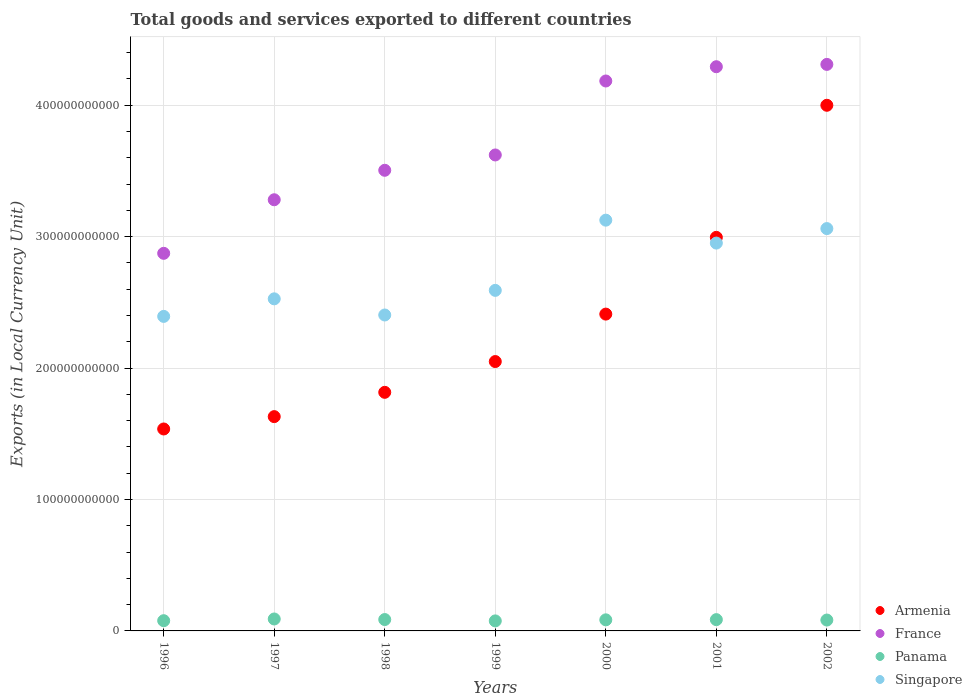How many different coloured dotlines are there?
Your response must be concise. 4. What is the Amount of goods and services exports in France in 1998?
Make the answer very short. 3.51e+11. Across all years, what is the maximum Amount of goods and services exports in Panama?
Offer a very short reply. 9.09e+09. Across all years, what is the minimum Amount of goods and services exports in Armenia?
Your answer should be very brief. 1.54e+11. In which year was the Amount of goods and services exports in France minimum?
Give a very brief answer. 1996. What is the total Amount of goods and services exports in France in the graph?
Ensure brevity in your answer.  2.61e+12. What is the difference between the Amount of goods and services exports in Armenia in 1996 and that in 2001?
Make the answer very short. -1.46e+11. What is the difference between the Amount of goods and services exports in France in 2000 and the Amount of goods and services exports in Singapore in 1996?
Keep it short and to the point. 1.79e+11. What is the average Amount of goods and services exports in Armenia per year?
Offer a terse response. 2.35e+11. In the year 1998, what is the difference between the Amount of goods and services exports in Singapore and Amount of goods and services exports in Panama?
Offer a terse response. 2.32e+11. What is the ratio of the Amount of goods and services exports in Singapore in 2000 to that in 2001?
Keep it short and to the point. 1.06. Is the Amount of goods and services exports in Singapore in 1997 less than that in 1998?
Provide a succinct answer. No. Is the difference between the Amount of goods and services exports in Singapore in 1997 and 1998 greater than the difference between the Amount of goods and services exports in Panama in 1997 and 1998?
Your response must be concise. Yes. What is the difference between the highest and the second highest Amount of goods and services exports in France?
Your response must be concise. 1.77e+09. What is the difference between the highest and the lowest Amount of goods and services exports in Panama?
Offer a terse response. 1.46e+09. Is the sum of the Amount of goods and services exports in Armenia in 1998 and 2000 greater than the maximum Amount of goods and services exports in Singapore across all years?
Provide a succinct answer. Yes. Is it the case that in every year, the sum of the Amount of goods and services exports in Panama and Amount of goods and services exports in France  is greater than the Amount of goods and services exports in Armenia?
Your response must be concise. Yes. Does the Amount of goods and services exports in Panama monotonically increase over the years?
Give a very brief answer. No. Is the Amount of goods and services exports in Panama strictly greater than the Amount of goods and services exports in France over the years?
Provide a short and direct response. No. What is the difference between two consecutive major ticks on the Y-axis?
Your response must be concise. 1.00e+11. Does the graph contain any zero values?
Provide a succinct answer. No. How are the legend labels stacked?
Offer a very short reply. Vertical. What is the title of the graph?
Give a very brief answer. Total goods and services exported to different countries. Does "Papua New Guinea" appear as one of the legend labels in the graph?
Give a very brief answer. No. What is the label or title of the X-axis?
Your response must be concise. Years. What is the label or title of the Y-axis?
Your answer should be compact. Exports (in Local Currency Unit). What is the Exports (in Local Currency Unit) in Armenia in 1996?
Ensure brevity in your answer.  1.54e+11. What is the Exports (in Local Currency Unit) of France in 1996?
Make the answer very short. 2.87e+11. What is the Exports (in Local Currency Unit) of Panama in 1996?
Make the answer very short. 7.78e+09. What is the Exports (in Local Currency Unit) of Singapore in 1996?
Give a very brief answer. 2.39e+11. What is the Exports (in Local Currency Unit) of Armenia in 1997?
Offer a terse response. 1.63e+11. What is the Exports (in Local Currency Unit) of France in 1997?
Your answer should be compact. 3.28e+11. What is the Exports (in Local Currency Unit) of Panama in 1997?
Your response must be concise. 9.09e+09. What is the Exports (in Local Currency Unit) of Singapore in 1997?
Ensure brevity in your answer.  2.53e+11. What is the Exports (in Local Currency Unit) in Armenia in 1998?
Your answer should be compact. 1.82e+11. What is the Exports (in Local Currency Unit) in France in 1998?
Your answer should be very brief. 3.51e+11. What is the Exports (in Local Currency Unit) in Panama in 1998?
Your answer should be very brief. 8.66e+09. What is the Exports (in Local Currency Unit) in Singapore in 1998?
Provide a succinct answer. 2.40e+11. What is the Exports (in Local Currency Unit) of Armenia in 1999?
Make the answer very short. 2.05e+11. What is the Exports (in Local Currency Unit) in France in 1999?
Keep it short and to the point. 3.62e+11. What is the Exports (in Local Currency Unit) of Panama in 1999?
Your response must be concise. 7.62e+09. What is the Exports (in Local Currency Unit) of Singapore in 1999?
Ensure brevity in your answer.  2.59e+11. What is the Exports (in Local Currency Unit) in Armenia in 2000?
Provide a short and direct response. 2.41e+11. What is the Exports (in Local Currency Unit) of France in 2000?
Your answer should be very brief. 4.18e+11. What is the Exports (in Local Currency Unit) in Panama in 2000?
Keep it short and to the point. 8.43e+09. What is the Exports (in Local Currency Unit) in Singapore in 2000?
Your answer should be very brief. 3.13e+11. What is the Exports (in Local Currency Unit) of Armenia in 2001?
Offer a very short reply. 2.99e+11. What is the Exports (in Local Currency Unit) of France in 2001?
Ensure brevity in your answer.  4.29e+11. What is the Exports (in Local Currency Unit) of Panama in 2001?
Provide a short and direct response. 8.59e+09. What is the Exports (in Local Currency Unit) in Singapore in 2001?
Ensure brevity in your answer.  2.95e+11. What is the Exports (in Local Currency Unit) in Armenia in 2002?
Offer a very short reply. 4.00e+11. What is the Exports (in Local Currency Unit) of France in 2002?
Ensure brevity in your answer.  4.31e+11. What is the Exports (in Local Currency Unit) of Panama in 2002?
Your answer should be compact. 8.28e+09. What is the Exports (in Local Currency Unit) of Singapore in 2002?
Your response must be concise. 3.06e+11. Across all years, what is the maximum Exports (in Local Currency Unit) of Armenia?
Your answer should be compact. 4.00e+11. Across all years, what is the maximum Exports (in Local Currency Unit) in France?
Provide a short and direct response. 4.31e+11. Across all years, what is the maximum Exports (in Local Currency Unit) in Panama?
Give a very brief answer. 9.09e+09. Across all years, what is the maximum Exports (in Local Currency Unit) of Singapore?
Provide a succinct answer. 3.13e+11. Across all years, what is the minimum Exports (in Local Currency Unit) in Armenia?
Offer a terse response. 1.54e+11. Across all years, what is the minimum Exports (in Local Currency Unit) of France?
Offer a terse response. 2.87e+11. Across all years, what is the minimum Exports (in Local Currency Unit) of Panama?
Your answer should be very brief. 7.62e+09. Across all years, what is the minimum Exports (in Local Currency Unit) of Singapore?
Your answer should be very brief. 2.39e+11. What is the total Exports (in Local Currency Unit) in Armenia in the graph?
Provide a succinct answer. 1.64e+12. What is the total Exports (in Local Currency Unit) of France in the graph?
Provide a succinct answer. 2.61e+12. What is the total Exports (in Local Currency Unit) in Panama in the graph?
Offer a very short reply. 5.84e+1. What is the total Exports (in Local Currency Unit) of Singapore in the graph?
Your response must be concise. 1.91e+12. What is the difference between the Exports (in Local Currency Unit) in Armenia in 1996 and that in 1997?
Give a very brief answer. -9.40e+09. What is the difference between the Exports (in Local Currency Unit) in France in 1996 and that in 1997?
Offer a terse response. -4.08e+1. What is the difference between the Exports (in Local Currency Unit) of Panama in 1996 and that in 1997?
Make the answer very short. -1.31e+09. What is the difference between the Exports (in Local Currency Unit) of Singapore in 1996 and that in 1997?
Provide a short and direct response. -1.34e+1. What is the difference between the Exports (in Local Currency Unit) of Armenia in 1996 and that in 1998?
Provide a succinct answer. -2.79e+1. What is the difference between the Exports (in Local Currency Unit) in France in 1996 and that in 1998?
Offer a terse response. -6.32e+1. What is the difference between the Exports (in Local Currency Unit) in Panama in 1996 and that in 1998?
Your answer should be very brief. -8.78e+08. What is the difference between the Exports (in Local Currency Unit) in Singapore in 1996 and that in 1998?
Provide a succinct answer. -1.06e+09. What is the difference between the Exports (in Local Currency Unit) in Armenia in 1996 and that in 1999?
Offer a very short reply. -5.13e+1. What is the difference between the Exports (in Local Currency Unit) of France in 1996 and that in 1999?
Keep it short and to the point. -7.49e+1. What is the difference between the Exports (in Local Currency Unit) in Panama in 1996 and that in 1999?
Your answer should be very brief. 1.55e+08. What is the difference between the Exports (in Local Currency Unit) of Singapore in 1996 and that in 1999?
Ensure brevity in your answer.  -1.98e+1. What is the difference between the Exports (in Local Currency Unit) of Armenia in 1996 and that in 2000?
Make the answer very short. -8.74e+1. What is the difference between the Exports (in Local Currency Unit) of France in 1996 and that in 2000?
Keep it short and to the point. -1.31e+11. What is the difference between the Exports (in Local Currency Unit) of Panama in 1996 and that in 2000?
Your answer should be compact. -6.56e+08. What is the difference between the Exports (in Local Currency Unit) of Singapore in 1996 and that in 2000?
Keep it short and to the point. -7.32e+1. What is the difference between the Exports (in Local Currency Unit) in Armenia in 1996 and that in 2001?
Your answer should be very brief. -1.46e+11. What is the difference between the Exports (in Local Currency Unit) of France in 1996 and that in 2001?
Your answer should be compact. -1.42e+11. What is the difference between the Exports (in Local Currency Unit) in Panama in 1996 and that in 2001?
Ensure brevity in your answer.  -8.09e+08. What is the difference between the Exports (in Local Currency Unit) of Singapore in 1996 and that in 2001?
Offer a very short reply. -5.58e+1. What is the difference between the Exports (in Local Currency Unit) in Armenia in 1996 and that in 2002?
Provide a succinct answer. -2.46e+11. What is the difference between the Exports (in Local Currency Unit) in France in 1996 and that in 2002?
Your answer should be very brief. -1.44e+11. What is the difference between the Exports (in Local Currency Unit) of Panama in 1996 and that in 2002?
Offer a very short reply. -5.01e+08. What is the difference between the Exports (in Local Currency Unit) of Singapore in 1996 and that in 2002?
Your answer should be very brief. -6.68e+1. What is the difference between the Exports (in Local Currency Unit) in Armenia in 1997 and that in 1998?
Make the answer very short. -1.85e+1. What is the difference between the Exports (in Local Currency Unit) in France in 1997 and that in 1998?
Offer a terse response. -2.24e+1. What is the difference between the Exports (in Local Currency Unit) in Panama in 1997 and that in 1998?
Give a very brief answer. 4.30e+08. What is the difference between the Exports (in Local Currency Unit) in Singapore in 1997 and that in 1998?
Provide a short and direct response. 1.23e+1. What is the difference between the Exports (in Local Currency Unit) in Armenia in 1997 and that in 1999?
Your answer should be very brief. -4.19e+1. What is the difference between the Exports (in Local Currency Unit) of France in 1997 and that in 1999?
Provide a short and direct response. -3.41e+1. What is the difference between the Exports (in Local Currency Unit) of Panama in 1997 and that in 1999?
Offer a very short reply. 1.46e+09. What is the difference between the Exports (in Local Currency Unit) in Singapore in 1997 and that in 1999?
Offer a terse response. -6.44e+09. What is the difference between the Exports (in Local Currency Unit) in Armenia in 1997 and that in 2000?
Your answer should be compact. -7.80e+1. What is the difference between the Exports (in Local Currency Unit) in France in 1997 and that in 2000?
Offer a very short reply. -9.04e+1. What is the difference between the Exports (in Local Currency Unit) of Panama in 1997 and that in 2000?
Your response must be concise. 6.53e+08. What is the difference between the Exports (in Local Currency Unit) of Singapore in 1997 and that in 2000?
Give a very brief answer. -5.99e+1. What is the difference between the Exports (in Local Currency Unit) of Armenia in 1997 and that in 2001?
Offer a terse response. -1.36e+11. What is the difference between the Exports (in Local Currency Unit) of France in 1997 and that in 2001?
Give a very brief answer. -1.01e+11. What is the difference between the Exports (in Local Currency Unit) in Panama in 1997 and that in 2001?
Your response must be concise. 5.00e+08. What is the difference between the Exports (in Local Currency Unit) in Singapore in 1997 and that in 2001?
Make the answer very short. -4.24e+1. What is the difference between the Exports (in Local Currency Unit) of Armenia in 1997 and that in 2002?
Keep it short and to the point. -2.37e+11. What is the difference between the Exports (in Local Currency Unit) in France in 1997 and that in 2002?
Your answer should be compact. -1.03e+11. What is the difference between the Exports (in Local Currency Unit) of Panama in 1997 and that in 2002?
Ensure brevity in your answer.  8.07e+08. What is the difference between the Exports (in Local Currency Unit) in Singapore in 1997 and that in 2002?
Your response must be concise. -5.35e+1. What is the difference between the Exports (in Local Currency Unit) in Armenia in 1998 and that in 1999?
Provide a succinct answer. -2.34e+1. What is the difference between the Exports (in Local Currency Unit) in France in 1998 and that in 1999?
Keep it short and to the point. -1.17e+1. What is the difference between the Exports (in Local Currency Unit) of Panama in 1998 and that in 1999?
Provide a succinct answer. 1.03e+09. What is the difference between the Exports (in Local Currency Unit) in Singapore in 1998 and that in 1999?
Provide a succinct answer. -1.87e+1. What is the difference between the Exports (in Local Currency Unit) of Armenia in 1998 and that in 2000?
Give a very brief answer. -5.95e+1. What is the difference between the Exports (in Local Currency Unit) in France in 1998 and that in 2000?
Your answer should be compact. -6.80e+1. What is the difference between the Exports (in Local Currency Unit) of Panama in 1998 and that in 2000?
Offer a very short reply. 2.22e+08. What is the difference between the Exports (in Local Currency Unit) in Singapore in 1998 and that in 2000?
Offer a terse response. -7.22e+1. What is the difference between the Exports (in Local Currency Unit) of Armenia in 1998 and that in 2001?
Provide a succinct answer. -1.18e+11. What is the difference between the Exports (in Local Currency Unit) of France in 1998 and that in 2001?
Offer a terse response. -7.88e+1. What is the difference between the Exports (in Local Currency Unit) in Panama in 1998 and that in 2001?
Keep it short and to the point. 6.96e+07. What is the difference between the Exports (in Local Currency Unit) of Singapore in 1998 and that in 2001?
Offer a very short reply. -5.47e+1. What is the difference between the Exports (in Local Currency Unit) of Armenia in 1998 and that in 2002?
Your answer should be very brief. -2.18e+11. What is the difference between the Exports (in Local Currency Unit) of France in 1998 and that in 2002?
Keep it short and to the point. -8.06e+1. What is the difference between the Exports (in Local Currency Unit) in Panama in 1998 and that in 2002?
Give a very brief answer. 3.77e+08. What is the difference between the Exports (in Local Currency Unit) in Singapore in 1998 and that in 2002?
Provide a short and direct response. -6.58e+1. What is the difference between the Exports (in Local Currency Unit) in Armenia in 1999 and that in 2000?
Keep it short and to the point. -3.61e+1. What is the difference between the Exports (in Local Currency Unit) of France in 1999 and that in 2000?
Give a very brief answer. -5.63e+1. What is the difference between the Exports (in Local Currency Unit) of Panama in 1999 and that in 2000?
Your answer should be compact. -8.11e+08. What is the difference between the Exports (in Local Currency Unit) in Singapore in 1999 and that in 2000?
Your response must be concise. -5.34e+1. What is the difference between the Exports (in Local Currency Unit) of Armenia in 1999 and that in 2001?
Your answer should be compact. -9.45e+1. What is the difference between the Exports (in Local Currency Unit) of France in 1999 and that in 2001?
Provide a succinct answer. -6.71e+1. What is the difference between the Exports (in Local Currency Unit) of Panama in 1999 and that in 2001?
Ensure brevity in your answer.  -9.64e+08. What is the difference between the Exports (in Local Currency Unit) in Singapore in 1999 and that in 2001?
Your answer should be compact. -3.60e+1. What is the difference between the Exports (in Local Currency Unit) of Armenia in 1999 and that in 2002?
Your response must be concise. -1.95e+11. What is the difference between the Exports (in Local Currency Unit) of France in 1999 and that in 2002?
Give a very brief answer. -6.89e+1. What is the difference between the Exports (in Local Currency Unit) of Panama in 1999 and that in 2002?
Provide a short and direct response. -6.56e+08. What is the difference between the Exports (in Local Currency Unit) of Singapore in 1999 and that in 2002?
Offer a very short reply. -4.70e+1. What is the difference between the Exports (in Local Currency Unit) in Armenia in 2000 and that in 2001?
Offer a very short reply. -5.84e+1. What is the difference between the Exports (in Local Currency Unit) of France in 2000 and that in 2001?
Your answer should be compact. -1.09e+1. What is the difference between the Exports (in Local Currency Unit) in Panama in 2000 and that in 2001?
Give a very brief answer. -1.53e+08. What is the difference between the Exports (in Local Currency Unit) in Singapore in 2000 and that in 2001?
Offer a very short reply. 1.74e+1. What is the difference between the Exports (in Local Currency Unit) in Armenia in 2000 and that in 2002?
Offer a very short reply. -1.59e+11. What is the difference between the Exports (in Local Currency Unit) of France in 2000 and that in 2002?
Provide a succinct answer. -1.26e+1. What is the difference between the Exports (in Local Currency Unit) of Panama in 2000 and that in 2002?
Ensure brevity in your answer.  1.55e+08. What is the difference between the Exports (in Local Currency Unit) of Singapore in 2000 and that in 2002?
Keep it short and to the point. 6.41e+09. What is the difference between the Exports (in Local Currency Unit) in Armenia in 2001 and that in 2002?
Offer a terse response. -1.00e+11. What is the difference between the Exports (in Local Currency Unit) in France in 2001 and that in 2002?
Keep it short and to the point. -1.77e+09. What is the difference between the Exports (in Local Currency Unit) in Panama in 2001 and that in 2002?
Offer a terse response. 3.08e+08. What is the difference between the Exports (in Local Currency Unit) of Singapore in 2001 and that in 2002?
Your answer should be very brief. -1.10e+1. What is the difference between the Exports (in Local Currency Unit) of Armenia in 1996 and the Exports (in Local Currency Unit) of France in 1997?
Offer a terse response. -1.74e+11. What is the difference between the Exports (in Local Currency Unit) in Armenia in 1996 and the Exports (in Local Currency Unit) in Panama in 1997?
Your answer should be compact. 1.45e+11. What is the difference between the Exports (in Local Currency Unit) of Armenia in 1996 and the Exports (in Local Currency Unit) of Singapore in 1997?
Provide a short and direct response. -9.90e+1. What is the difference between the Exports (in Local Currency Unit) in France in 1996 and the Exports (in Local Currency Unit) in Panama in 1997?
Offer a terse response. 2.78e+11. What is the difference between the Exports (in Local Currency Unit) of France in 1996 and the Exports (in Local Currency Unit) of Singapore in 1997?
Keep it short and to the point. 3.46e+1. What is the difference between the Exports (in Local Currency Unit) of Panama in 1996 and the Exports (in Local Currency Unit) of Singapore in 1997?
Make the answer very short. -2.45e+11. What is the difference between the Exports (in Local Currency Unit) of Armenia in 1996 and the Exports (in Local Currency Unit) of France in 1998?
Keep it short and to the point. -1.97e+11. What is the difference between the Exports (in Local Currency Unit) in Armenia in 1996 and the Exports (in Local Currency Unit) in Panama in 1998?
Provide a succinct answer. 1.45e+11. What is the difference between the Exports (in Local Currency Unit) in Armenia in 1996 and the Exports (in Local Currency Unit) in Singapore in 1998?
Offer a very short reply. -8.67e+1. What is the difference between the Exports (in Local Currency Unit) of France in 1996 and the Exports (in Local Currency Unit) of Panama in 1998?
Keep it short and to the point. 2.79e+11. What is the difference between the Exports (in Local Currency Unit) of France in 1996 and the Exports (in Local Currency Unit) of Singapore in 1998?
Your response must be concise. 4.69e+1. What is the difference between the Exports (in Local Currency Unit) in Panama in 1996 and the Exports (in Local Currency Unit) in Singapore in 1998?
Your answer should be very brief. -2.33e+11. What is the difference between the Exports (in Local Currency Unit) of Armenia in 1996 and the Exports (in Local Currency Unit) of France in 1999?
Provide a succinct answer. -2.09e+11. What is the difference between the Exports (in Local Currency Unit) in Armenia in 1996 and the Exports (in Local Currency Unit) in Panama in 1999?
Ensure brevity in your answer.  1.46e+11. What is the difference between the Exports (in Local Currency Unit) of Armenia in 1996 and the Exports (in Local Currency Unit) of Singapore in 1999?
Keep it short and to the point. -1.05e+11. What is the difference between the Exports (in Local Currency Unit) in France in 1996 and the Exports (in Local Currency Unit) in Panama in 1999?
Provide a succinct answer. 2.80e+11. What is the difference between the Exports (in Local Currency Unit) in France in 1996 and the Exports (in Local Currency Unit) in Singapore in 1999?
Your answer should be very brief. 2.82e+1. What is the difference between the Exports (in Local Currency Unit) in Panama in 1996 and the Exports (in Local Currency Unit) in Singapore in 1999?
Ensure brevity in your answer.  -2.51e+11. What is the difference between the Exports (in Local Currency Unit) of Armenia in 1996 and the Exports (in Local Currency Unit) of France in 2000?
Give a very brief answer. -2.65e+11. What is the difference between the Exports (in Local Currency Unit) in Armenia in 1996 and the Exports (in Local Currency Unit) in Panama in 2000?
Offer a terse response. 1.45e+11. What is the difference between the Exports (in Local Currency Unit) of Armenia in 1996 and the Exports (in Local Currency Unit) of Singapore in 2000?
Make the answer very short. -1.59e+11. What is the difference between the Exports (in Local Currency Unit) of France in 1996 and the Exports (in Local Currency Unit) of Panama in 2000?
Provide a short and direct response. 2.79e+11. What is the difference between the Exports (in Local Currency Unit) of France in 1996 and the Exports (in Local Currency Unit) of Singapore in 2000?
Provide a short and direct response. -2.52e+1. What is the difference between the Exports (in Local Currency Unit) in Panama in 1996 and the Exports (in Local Currency Unit) in Singapore in 2000?
Offer a terse response. -3.05e+11. What is the difference between the Exports (in Local Currency Unit) in Armenia in 1996 and the Exports (in Local Currency Unit) in France in 2001?
Offer a very short reply. -2.76e+11. What is the difference between the Exports (in Local Currency Unit) in Armenia in 1996 and the Exports (in Local Currency Unit) in Panama in 2001?
Give a very brief answer. 1.45e+11. What is the difference between the Exports (in Local Currency Unit) of Armenia in 1996 and the Exports (in Local Currency Unit) of Singapore in 2001?
Keep it short and to the point. -1.41e+11. What is the difference between the Exports (in Local Currency Unit) of France in 1996 and the Exports (in Local Currency Unit) of Panama in 2001?
Provide a short and direct response. 2.79e+11. What is the difference between the Exports (in Local Currency Unit) in France in 1996 and the Exports (in Local Currency Unit) in Singapore in 2001?
Give a very brief answer. -7.80e+09. What is the difference between the Exports (in Local Currency Unit) in Panama in 1996 and the Exports (in Local Currency Unit) in Singapore in 2001?
Make the answer very short. -2.87e+11. What is the difference between the Exports (in Local Currency Unit) of Armenia in 1996 and the Exports (in Local Currency Unit) of France in 2002?
Keep it short and to the point. -2.77e+11. What is the difference between the Exports (in Local Currency Unit) in Armenia in 1996 and the Exports (in Local Currency Unit) in Panama in 2002?
Your answer should be compact. 1.45e+11. What is the difference between the Exports (in Local Currency Unit) of Armenia in 1996 and the Exports (in Local Currency Unit) of Singapore in 2002?
Ensure brevity in your answer.  -1.52e+11. What is the difference between the Exports (in Local Currency Unit) of France in 1996 and the Exports (in Local Currency Unit) of Panama in 2002?
Make the answer very short. 2.79e+11. What is the difference between the Exports (in Local Currency Unit) of France in 1996 and the Exports (in Local Currency Unit) of Singapore in 2002?
Ensure brevity in your answer.  -1.88e+1. What is the difference between the Exports (in Local Currency Unit) of Panama in 1996 and the Exports (in Local Currency Unit) of Singapore in 2002?
Provide a succinct answer. -2.98e+11. What is the difference between the Exports (in Local Currency Unit) of Armenia in 1997 and the Exports (in Local Currency Unit) of France in 1998?
Provide a succinct answer. -1.87e+11. What is the difference between the Exports (in Local Currency Unit) in Armenia in 1997 and the Exports (in Local Currency Unit) in Panama in 1998?
Keep it short and to the point. 1.54e+11. What is the difference between the Exports (in Local Currency Unit) of Armenia in 1997 and the Exports (in Local Currency Unit) of Singapore in 1998?
Offer a very short reply. -7.73e+1. What is the difference between the Exports (in Local Currency Unit) of France in 1997 and the Exports (in Local Currency Unit) of Panama in 1998?
Make the answer very short. 3.19e+11. What is the difference between the Exports (in Local Currency Unit) of France in 1997 and the Exports (in Local Currency Unit) of Singapore in 1998?
Your answer should be compact. 8.77e+1. What is the difference between the Exports (in Local Currency Unit) in Panama in 1997 and the Exports (in Local Currency Unit) in Singapore in 1998?
Your answer should be very brief. -2.31e+11. What is the difference between the Exports (in Local Currency Unit) in Armenia in 1997 and the Exports (in Local Currency Unit) in France in 1999?
Offer a very short reply. -1.99e+11. What is the difference between the Exports (in Local Currency Unit) in Armenia in 1997 and the Exports (in Local Currency Unit) in Panama in 1999?
Keep it short and to the point. 1.55e+11. What is the difference between the Exports (in Local Currency Unit) in Armenia in 1997 and the Exports (in Local Currency Unit) in Singapore in 1999?
Give a very brief answer. -9.61e+1. What is the difference between the Exports (in Local Currency Unit) of France in 1997 and the Exports (in Local Currency Unit) of Panama in 1999?
Your answer should be very brief. 3.20e+11. What is the difference between the Exports (in Local Currency Unit) of France in 1997 and the Exports (in Local Currency Unit) of Singapore in 1999?
Your answer should be compact. 6.90e+1. What is the difference between the Exports (in Local Currency Unit) in Panama in 1997 and the Exports (in Local Currency Unit) in Singapore in 1999?
Make the answer very short. -2.50e+11. What is the difference between the Exports (in Local Currency Unit) of Armenia in 1997 and the Exports (in Local Currency Unit) of France in 2000?
Offer a terse response. -2.55e+11. What is the difference between the Exports (in Local Currency Unit) in Armenia in 1997 and the Exports (in Local Currency Unit) in Panama in 2000?
Your answer should be compact. 1.55e+11. What is the difference between the Exports (in Local Currency Unit) of Armenia in 1997 and the Exports (in Local Currency Unit) of Singapore in 2000?
Your answer should be very brief. -1.49e+11. What is the difference between the Exports (in Local Currency Unit) of France in 1997 and the Exports (in Local Currency Unit) of Panama in 2000?
Provide a short and direct response. 3.20e+11. What is the difference between the Exports (in Local Currency Unit) of France in 1997 and the Exports (in Local Currency Unit) of Singapore in 2000?
Ensure brevity in your answer.  1.55e+1. What is the difference between the Exports (in Local Currency Unit) in Panama in 1997 and the Exports (in Local Currency Unit) in Singapore in 2000?
Keep it short and to the point. -3.03e+11. What is the difference between the Exports (in Local Currency Unit) in Armenia in 1997 and the Exports (in Local Currency Unit) in France in 2001?
Offer a very short reply. -2.66e+11. What is the difference between the Exports (in Local Currency Unit) of Armenia in 1997 and the Exports (in Local Currency Unit) of Panama in 2001?
Give a very brief answer. 1.54e+11. What is the difference between the Exports (in Local Currency Unit) of Armenia in 1997 and the Exports (in Local Currency Unit) of Singapore in 2001?
Make the answer very short. -1.32e+11. What is the difference between the Exports (in Local Currency Unit) of France in 1997 and the Exports (in Local Currency Unit) of Panama in 2001?
Give a very brief answer. 3.20e+11. What is the difference between the Exports (in Local Currency Unit) of France in 1997 and the Exports (in Local Currency Unit) of Singapore in 2001?
Make the answer very short. 3.30e+1. What is the difference between the Exports (in Local Currency Unit) in Panama in 1997 and the Exports (in Local Currency Unit) in Singapore in 2001?
Keep it short and to the point. -2.86e+11. What is the difference between the Exports (in Local Currency Unit) in Armenia in 1997 and the Exports (in Local Currency Unit) in France in 2002?
Make the answer very short. -2.68e+11. What is the difference between the Exports (in Local Currency Unit) in Armenia in 1997 and the Exports (in Local Currency Unit) in Panama in 2002?
Offer a terse response. 1.55e+11. What is the difference between the Exports (in Local Currency Unit) of Armenia in 1997 and the Exports (in Local Currency Unit) of Singapore in 2002?
Keep it short and to the point. -1.43e+11. What is the difference between the Exports (in Local Currency Unit) of France in 1997 and the Exports (in Local Currency Unit) of Panama in 2002?
Give a very brief answer. 3.20e+11. What is the difference between the Exports (in Local Currency Unit) of France in 1997 and the Exports (in Local Currency Unit) of Singapore in 2002?
Your answer should be very brief. 2.19e+1. What is the difference between the Exports (in Local Currency Unit) of Panama in 1997 and the Exports (in Local Currency Unit) of Singapore in 2002?
Your answer should be very brief. -2.97e+11. What is the difference between the Exports (in Local Currency Unit) in Armenia in 1998 and the Exports (in Local Currency Unit) in France in 1999?
Your response must be concise. -1.81e+11. What is the difference between the Exports (in Local Currency Unit) in Armenia in 1998 and the Exports (in Local Currency Unit) in Panama in 1999?
Give a very brief answer. 1.74e+11. What is the difference between the Exports (in Local Currency Unit) of Armenia in 1998 and the Exports (in Local Currency Unit) of Singapore in 1999?
Keep it short and to the point. -7.76e+1. What is the difference between the Exports (in Local Currency Unit) of France in 1998 and the Exports (in Local Currency Unit) of Panama in 1999?
Keep it short and to the point. 3.43e+11. What is the difference between the Exports (in Local Currency Unit) in France in 1998 and the Exports (in Local Currency Unit) in Singapore in 1999?
Your response must be concise. 9.14e+1. What is the difference between the Exports (in Local Currency Unit) of Panama in 1998 and the Exports (in Local Currency Unit) of Singapore in 1999?
Ensure brevity in your answer.  -2.50e+11. What is the difference between the Exports (in Local Currency Unit) of Armenia in 1998 and the Exports (in Local Currency Unit) of France in 2000?
Provide a succinct answer. -2.37e+11. What is the difference between the Exports (in Local Currency Unit) of Armenia in 1998 and the Exports (in Local Currency Unit) of Panama in 2000?
Your response must be concise. 1.73e+11. What is the difference between the Exports (in Local Currency Unit) in Armenia in 1998 and the Exports (in Local Currency Unit) in Singapore in 2000?
Offer a very short reply. -1.31e+11. What is the difference between the Exports (in Local Currency Unit) of France in 1998 and the Exports (in Local Currency Unit) of Panama in 2000?
Offer a very short reply. 3.42e+11. What is the difference between the Exports (in Local Currency Unit) of France in 1998 and the Exports (in Local Currency Unit) of Singapore in 2000?
Give a very brief answer. 3.79e+1. What is the difference between the Exports (in Local Currency Unit) of Panama in 1998 and the Exports (in Local Currency Unit) of Singapore in 2000?
Offer a very short reply. -3.04e+11. What is the difference between the Exports (in Local Currency Unit) in Armenia in 1998 and the Exports (in Local Currency Unit) in France in 2001?
Provide a short and direct response. -2.48e+11. What is the difference between the Exports (in Local Currency Unit) in Armenia in 1998 and the Exports (in Local Currency Unit) in Panama in 2001?
Your answer should be compact. 1.73e+11. What is the difference between the Exports (in Local Currency Unit) of Armenia in 1998 and the Exports (in Local Currency Unit) of Singapore in 2001?
Provide a succinct answer. -1.14e+11. What is the difference between the Exports (in Local Currency Unit) of France in 1998 and the Exports (in Local Currency Unit) of Panama in 2001?
Offer a very short reply. 3.42e+11. What is the difference between the Exports (in Local Currency Unit) in France in 1998 and the Exports (in Local Currency Unit) in Singapore in 2001?
Provide a short and direct response. 5.54e+1. What is the difference between the Exports (in Local Currency Unit) in Panama in 1998 and the Exports (in Local Currency Unit) in Singapore in 2001?
Give a very brief answer. -2.86e+11. What is the difference between the Exports (in Local Currency Unit) of Armenia in 1998 and the Exports (in Local Currency Unit) of France in 2002?
Make the answer very short. -2.50e+11. What is the difference between the Exports (in Local Currency Unit) of Armenia in 1998 and the Exports (in Local Currency Unit) of Panama in 2002?
Ensure brevity in your answer.  1.73e+11. What is the difference between the Exports (in Local Currency Unit) in Armenia in 1998 and the Exports (in Local Currency Unit) in Singapore in 2002?
Give a very brief answer. -1.25e+11. What is the difference between the Exports (in Local Currency Unit) in France in 1998 and the Exports (in Local Currency Unit) in Panama in 2002?
Offer a very short reply. 3.42e+11. What is the difference between the Exports (in Local Currency Unit) in France in 1998 and the Exports (in Local Currency Unit) in Singapore in 2002?
Give a very brief answer. 4.44e+1. What is the difference between the Exports (in Local Currency Unit) of Panama in 1998 and the Exports (in Local Currency Unit) of Singapore in 2002?
Your answer should be compact. -2.97e+11. What is the difference between the Exports (in Local Currency Unit) of Armenia in 1999 and the Exports (in Local Currency Unit) of France in 2000?
Your answer should be very brief. -2.13e+11. What is the difference between the Exports (in Local Currency Unit) in Armenia in 1999 and the Exports (in Local Currency Unit) in Panama in 2000?
Provide a short and direct response. 1.97e+11. What is the difference between the Exports (in Local Currency Unit) of Armenia in 1999 and the Exports (in Local Currency Unit) of Singapore in 2000?
Offer a terse response. -1.08e+11. What is the difference between the Exports (in Local Currency Unit) in France in 1999 and the Exports (in Local Currency Unit) in Panama in 2000?
Your answer should be very brief. 3.54e+11. What is the difference between the Exports (in Local Currency Unit) of France in 1999 and the Exports (in Local Currency Unit) of Singapore in 2000?
Make the answer very short. 4.96e+1. What is the difference between the Exports (in Local Currency Unit) in Panama in 1999 and the Exports (in Local Currency Unit) in Singapore in 2000?
Offer a terse response. -3.05e+11. What is the difference between the Exports (in Local Currency Unit) in Armenia in 1999 and the Exports (in Local Currency Unit) in France in 2001?
Provide a short and direct response. -2.24e+11. What is the difference between the Exports (in Local Currency Unit) in Armenia in 1999 and the Exports (in Local Currency Unit) in Panama in 2001?
Your answer should be very brief. 1.96e+11. What is the difference between the Exports (in Local Currency Unit) in Armenia in 1999 and the Exports (in Local Currency Unit) in Singapore in 2001?
Ensure brevity in your answer.  -9.01e+1. What is the difference between the Exports (in Local Currency Unit) in France in 1999 and the Exports (in Local Currency Unit) in Panama in 2001?
Your response must be concise. 3.54e+11. What is the difference between the Exports (in Local Currency Unit) in France in 1999 and the Exports (in Local Currency Unit) in Singapore in 2001?
Provide a succinct answer. 6.71e+1. What is the difference between the Exports (in Local Currency Unit) in Panama in 1999 and the Exports (in Local Currency Unit) in Singapore in 2001?
Offer a very short reply. -2.87e+11. What is the difference between the Exports (in Local Currency Unit) in Armenia in 1999 and the Exports (in Local Currency Unit) in France in 2002?
Ensure brevity in your answer.  -2.26e+11. What is the difference between the Exports (in Local Currency Unit) in Armenia in 1999 and the Exports (in Local Currency Unit) in Panama in 2002?
Provide a succinct answer. 1.97e+11. What is the difference between the Exports (in Local Currency Unit) of Armenia in 1999 and the Exports (in Local Currency Unit) of Singapore in 2002?
Provide a succinct answer. -1.01e+11. What is the difference between the Exports (in Local Currency Unit) in France in 1999 and the Exports (in Local Currency Unit) in Panama in 2002?
Your response must be concise. 3.54e+11. What is the difference between the Exports (in Local Currency Unit) in France in 1999 and the Exports (in Local Currency Unit) in Singapore in 2002?
Ensure brevity in your answer.  5.60e+1. What is the difference between the Exports (in Local Currency Unit) of Panama in 1999 and the Exports (in Local Currency Unit) of Singapore in 2002?
Make the answer very short. -2.99e+11. What is the difference between the Exports (in Local Currency Unit) in Armenia in 2000 and the Exports (in Local Currency Unit) in France in 2001?
Offer a very short reply. -1.88e+11. What is the difference between the Exports (in Local Currency Unit) in Armenia in 2000 and the Exports (in Local Currency Unit) in Panama in 2001?
Your answer should be compact. 2.32e+11. What is the difference between the Exports (in Local Currency Unit) of Armenia in 2000 and the Exports (in Local Currency Unit) of Singapore in 2001?
Give a very brief answer. -5.40e+1. What is the difference between the Exports (in Local Currency Unit) of France in 2000 and the Exports (in Local Currency Unit) of Panama in 2001?
Offer a terse response. 4.10e+11. What is the difference between the Exports (in Local Currency Unit) in France in 2000 and the Exports (in Local Currency Unit) in Singapore in 2001?
Offer a very short reply. 1.23e+11. What is the difference between the Exports (in Local Currency Unit) in Panama in 2000 and the Exports (in Local Currency Unit) in Singapore in 2001?
Keep it short and to the point. -2.87e+11. What is the difference between the Exports (in Local Currency Unit) of Armenia in 2000 and the Exports (in Local Currency Unit) of France in 2002?
Provide a succinct answer. -1.90e+11. What is the difference between the Exports (in Local Currency Unit) of Armenia in 2000 and the Exports (in Local Currency Unit) of Panama in 2002?
Provide a succinct answer. 2.33e+11. What is the difference between the Exports (in Local Currency Unit) of Armenia in 2000 and the Exports (in Local Currency Unit) of Singapore in 2002?
Your answer should be compact. -6.51e+1. What is the difference between the Exports (in Local Currency Unit) in France in 2000 and the Exports (in Local Currency Unit) in Panama in 2002?
Your response must be concise. 4.10e+11. What is the difference between the Exports (in Local Currency Unit) in France in 2000 and the Exports (in Local Currency Unit) in Singapore in 2002?
Make the answer very short. 1.12e+11. What is the difference between the Exports (in Local Currency Unit) in Panama in 2000 and the Exports (in Local Currency Unit) in Singapore in 2002?
Make the answer very short. -2.98e+11. What is the difference between the Exports (in Local Currency Unit) of Armenia in 2001 and the Exports (in Local Currency Unit) of France in 2002?
Offer a terse response. -1.32e+11. What is the difference between the Exports (in Local Currency Unit) of Armenia in 2001 and the Exports (in Local Currency Unit) of Panama in 2002?
Your answer should be compact. 2.91e+11. What is the difference between the Exports (in Local Currency Unit) of Armenia in 2001 and the Exports (in Local Currency Unit) of Singapore in 2002?
Provide a short and direct response. -6.68e+09. What is the difference between the Exports (in Local Currency Unit) in France in 2001 and the Exports (in Local Currency Unit) in Panama in 2002?
Offer a terse response. 4.21e+11. What is the difference between the Exports (in Local Currency Unit) of France in 2001 and the Exports (in Local Currency Unit) of Singapore in 2002?
Offer a terse response. 1.23e+11. What is the difference between the Exports (in Local Currency Unit) of Panama in 2001 and the Exports (in Local Currency Unit) of Singapore in 2002?
Ensure brevity in your answer.  -2.98e+11. What is the average Exports (in Local Currency Unit) in Armenia per year?
Keep it short and to the point. 2.35e+11. What is the average Exports (in Local Currency Unit) in France per year?
Provide a short and direct response. 3.72e+11. What is the average Exports (in Local Currency Unit) in Panama per year?
Make the answer very short. 8.35e+09. What is the average Exports (in Local Currency Unit) of Singapore per year?
Provide a short and direct response. 2.72e+11. In the year 1996, what is the difference between the Exports (in Local Currency Unit) in Armenia and Exports (in Local Currency Unit) in France?
Ensure brevity in your answer.  -1.34e+11. In the year 1996, what is the difference between the Exports (in Local Currency Unit) of Armenia and Exports (in Local Currency Unit) of Panama?
Offer a very short reply. 1.46e+11. In the year 1996, what is the difference between the Exports (in Local Currency Unit) of Armenia and Exports (in Local Currency Unit) of Singapore?
Keep it short and to the point. -8.57e+1. In the year 1996, what is the difference between the Exports (in Local Currency Unit) of France and Exports (in Local Currency Unit) of Panama?
Provide a short and direct response. 2.80e+11. In the year 1996, what is the difference between the Exports (in Local Currency Unit) in France and Exports (in Local Currency Unit) in Singapore?
Your response must be concise. 4.80e+1. In the year 1996, what is the difference between the Exports (in Local Currency Unit) in Panama and Exports (in Local Currency Unit) in Singapore?
Your answer should be very brief. -2.32e+11. In the year 1997, what is the difference between the Exports (in Local Currency Unit) in Armenia and Exports (in Local Currency Unit) in France?
Offer a very short reply. -1.65e+11. In the year 1997, what is the difference between the Exports (in Local Currency Unit) of Armenia and Exports (in Local Currency Unit) of Panama?
Offer a terse response. 1.54e+11. In the year 1997, what is the difference between the Exports (in Local Currency Unit) of Armenia and Exports (in Local Currency Unit) of Singapore?
Ensure brevity in your answer.  -8.96e+1. In the year 1997, what is the difference between the Exports (in Local Currency Unit) in France and Exports (in Local Currency Unit) in Panama?
Your answer should be compact. 3.19e+11. In the year 1997, what is the difference between the Exports (in Local Currency Unit) in France and Exports (in Local Currency Unit) in Singapore?
Offer a very short reply. 7.54e+1. In the year 1997, what is the difference between the Exports (in Local Currency Unit) in Panama and Exports (in Local Currency Unit) in Singapore?
Provide a succinct answer. -2.44e+11. In the year 1998, what is the difference between the Exports (in Local Currency Unit) in Armenia and Exports (in Local Currency Unit) in France?
Your response must be concise. -1.69e+11. In the year 1998, what is the difference between the Exports (in Local Currency Unit) in Armenia and Exports (in Local Currency Unit) in Panama?
Your answer should be very brief. 1.73e+11. In the year 1998, what is the difference between the Exports (in Local Currency Unit) of Armenia and Exports (in Local Currency Unit) of Singapore?
Offer a terse response. -5.88e+1. In the year 1998, what is the difference between the Exports (in Local Currency Unit) in France and Exports (in Local Currency Unit) in Panama?
Offer a terse response. 3.42e+11. In the year 1998, what is the difference between the Exports (in Local Currency Unit) of France and Exports (in Local Currency Unit) of Singapore?
Your answer should be very brief. 1.10e+11. In the year 1998, what is the difference between the Exports (in Local Currency Unit) of Panama and Exports (in Local Currency Unit) of Singapore?
Provide a succinct answer. -2.32e+11. In the year 1999, what is the difference between the Exports (in Local Currency Unit) in Armenia and Exports (in Local Currency Unit) in France?
Your answer should be very brief. -1.57e+11. In the year 1999, what is the difference between the Exports (in Local Currency Unit) in Armenia and Exports (in Local Currency Unit) in Panama?
Your response must be concise. 1.97e+11. In the year 1999, what is the difference between the Exports (in Local Currency Unit) in Armenia and Exports (in Local Currency Unit) in Singapore?
Your response must be concise. -5.42e+1. In the year 1999, what is the difference between the Exports (in Local Currency Unit) of France and Exports (in Local Currency Unit) of Panama?
Offer a terse response. 3.55e+11. In the year 1999, what is the difference between the Exports (in Local Currency Unit) of France and Exports (in Local Currency Unit) of Singapore?
Make the answer very short. 1.03e+11. In the year 1999, what is the difference between the Exports (in Local Currency Unit) in Panama and Exports (in Local Currency Unit) in Singapore?
Ensure brevity in your answer.  -2.52e+11. In the year 2000, what is the difference between the Exports (in Local Currency Unit) of Armenia and Exports (in Local Currency Unit) of France?
Provide a succinct answer. -1.77e+11. In the year 2000, what is the difference between the Exports (in Local Currency Unit) in Armenia and Exports (in Local Currency Unit) in Panama?
Make the answer very short. 2.33e+11. In the year 2000, what is the difference between the Exports (in Local Currency Unit) of Armenia and Exports (in Local Currency Unit) of Singapore?
Your response must be concise. -7.15e+1. In the year 2000, what is the difference between the Exports (in Local Currency Unit) of France and Exports (in Local Currency Unit) of Panama?
Your answer should be compact. 4.10e+11. In the year 2000, what is the difference between the Exports (in Local Currency Unit) in France and Exports (in Local Currency Unit) in Singapore?
Ensure brevity in your answer.  1.06e+11. In the year 2000, what is the difference between the Exports (in Local Currency Unit) of Panama and Exports (in Local Currency Unit) of Singapore?
Provide a short and direct response. -3.04e+11. In the year 2001, what is the difference between the Exports (in Local Currency Unit) in Armenia and Exports (in Local Currency Unit) in France?
Keep it short and to the point. -1.30e+11. In the year 2001, what is the difference between the Exports (in Local Currency Unit) of Armenia and Exports (in Local Currency Unit) of Panama?
Provide a succinct answer. 2.91e+11. In the year 2001, what is the difference between the Exports (in Local Currency Unit) in Armenia and Exports (in Local Currency Unit) in Singapore?
Make the answer very short. 4.36e+09. In the year 2001, what is the difference between the Exports (in Local Currency Unit) in France and Exports (in Local Currency Unit) in Panama?
Make the answer very short. 4.21e+11. In the year 2001, what is the difference between the Exports (in Local Currency Unit) in France and Exports (in Local Currency Unit) in Singapore?
Your answer should be compact. 1.34e+11. In the year 2001, what is the difference between the Exports (in Local Currency Unit) in Panama and Exports (in Local Currency Unit) in Singapore?
Give a very brief answer. -2.87e+11. In the year 2002, what is the difference between the Exports (in Local Currency Unit) of Armenia and Exports (in Local Currency Unit) of France?
Your answer should be compact. -3.11e+1. In the year 2002, what is the difference between the Exports (in Local Currency Unit) of Armenia and Exports (in Local Currency Unit) of Panama?
Make the answer very short. 3.92e+11. In the year 2002, what is the difference between the Exports (in Local Currency Unit) in Armenia and Exports (in Local Currency Unit) in Singapore?
Offer a terse response. 9.38e+1. In the year 2002, what is the difference between the Exports (in Local Currency Unit) of France and Exports (in Local Currency Unit) of Panama?
Offer a very short reply. 4.23e+11. In the year 2002, what is the difference between the Exports (in Local Currency Unit) in France and Exports (in Local Currency Unit) in Singapore?
Give a very brief answer. 1.25e+11. In the year 2002, what is the difference between the Exports (in Local Currency Unit) of Panama and Exports (in Local Currency Unit) of Singapore?
Provide a succinct answer. -2.98e+11. What is the ratio of the Exports (in Local Currency Unit) of Armenia in 1996 to that in 1997?
Ensure brevity in your answer.  0.94. What is the ratio of the Exports (in Local Currency Unit) of France in 1996 to that in 1997?
Offer a very short reply. 0.88. What is the ratio of the Exports (in Local Currency Unit) of Panama in 1996 to that in 1997?
Provide a succinct answer. 0.86. What is the ratio of the Exports (in Local Currency Unit) of Singapore in 1996 to that in 1997?
Your answer should be very brief. 0.95. What is the ratio of the Exports (in Local Currency Unit) in Armenia in 1996 to that in 1998?
Provide a short and direct response. 0.85. What is the ratio of the Exports (in Local Currency Unit) of France in 1996 to that in 1998?
Your answer should be compact. 0.82. What is the ratio of the Exports (in Local Currency Unit) in Panama in 1996 to that in 1998?
Provide a short and direct response. 0.9. What is the ratio of the Exports (in Local Currency Unit) in Singapore in 1996 to that in 1998?
Provide a succinct answer. 1. What is the ratio of the Exports (in Local Currency Unit) in Armenia in 1996 to that in 1999?
Ensure brevity in your answer.  0.75. What is the ratio of the Exports (in Local Currency Unit) of France in 1996 to that in 1999?
Keep it short and to the point. 0.79. What is the ratio of the Exports (in Local Currency Unit) of Panama in 1996 to that in 1999?
Give a very brief answer. 1.02. What is the ratio of the Exports (in Local Currency Unit) of Singapore in 1996 to that in 1999?
Your answer should be very brief. 0.92. What is the ratio of the Exports (in Local Currency Unit) of Armenia in 1996 to that in 2000?
Offer a terse response. 0.64. What is the ratio of the Exports (in Local Currency Unit) in France in 1996 to that in 2000?
Give a very brief answer. 0.69. What is the ratio of the Exports (in Local Currency Unit) in Panama in 1996 to that in 2000?
Provide a short and direct response. 0.92. What is the ratio of the Exports (in Local Currency Unit) of Singapore in 1996 to that in 2000?
Offer a very short reply. 0.77. What is the ratio of the Exports (in Local Currency Unit) in Armenia in 1996 to that in 2001?
Provide a short and direct response. 0.51. What is the ratio of the Exports (in Local Currency Unit) in France in 1996 to that in 2001?
Your response must be concise. 0.67. What is the ratio of the Exports (in Local Currency Unit) of Panama in 1996 to that in 2001?
Keep it short and to the point. 0.91. What is the ratio of the Exports (in Local Currency Unit) of Singapore in 1996 to that in 2001?
Your answer should be compact. 0.81. What is the ratio of the Exports (in Local Currency Unit) of Armenia in 1996 to that in 2002?
Make the answer very short. 0.38. What is the ratio of the Exports (in Local Currency Unit) in France in 1996 to that in 2002?
Give a very brief answer. 0.67. What is the ratio of the Exports (in Local Currency Unit) of Panama in 1996 to that in 2002?
Provide a short and direct response. 0.94. What is the ratio of the Exports (in Local Currency Unit) in Singapore in 1996 to that in 2002?
Your answer should be compact. 0.78. What is the ratio of the Exports (in Local Currency Unit) of Armenia in 1997 to that in 1998?
Your answer should be compact. 0.9. What is the ratio of the Exports (in Local Currency Unit) in France in 1997 to that in 1998?
Ensure brevity in your answer.  0.94. What is the ratio of the Exports (in Local Currency Unit) in Panama in 1997 to that in 1998?
Provide a succinct answer. 1.05. What is the ratio of the Exports (in Local Currency Unit) of Singapore in 1997 to that in 1998?
Your answer should be compact. 1.05. What is the ratio of the Exports (in Local Currency Unit) of Armenia in 1997 to that in 1999?
Your answer should be compact. 0.8. What is the ratio of the Exports (in Local Currency Unit) in France in 1997 to that in 1999?
Offer a terse response. 0.91. What is the ratio of the Exports (in Local Currency Unit) of Panama in 1997 to that in 1999?
Make the answer very short. 1.19. What is the ratio of the Exports (in Local Currency Unit) of Singapore in 1997 to that in 1999?
Offer a terse response. 0.98. What is the ratio of the Exports (in Local Currency Unit) of Armenia in 1997 to that in 2000?
Keep it short and to the point. 0.68. What is the ratio of the Exports (in Local Currency Unit) of France in 1997 to that in 2000?
Your response must be concise. 0.78. What is the ratio of the Exports (in Local Currency Unit) of Panama in 1997 to that in 2000?
Offer a very short reply. 1.08. What is the ratio of the Exports (in Local Currency Unit) of Singapore in 1997 to that in 2000?
Ensure brevity in your answer.  0.81. What is the ratio of the Exports (in Local Currency Unit) in Armenia in 1997 to that in 2001?
Make the answer very short. 0.54. What is the ratio of the Exports (in Local Currency Unit) in France in 1997 to that in 2001?
Offer a terse response. 0.76. What is the ratio of the Exports (in Local Currency Unit) of Panama in 1997 to that in 2001?
Make the answer very short. 1.06. What is the ratio of the Exports (in Local Currency Unit) of Singapore in 1997 to that in 2001?
Your answer should be very brief. 0.86. What is the ratio of the Exports (in Local Currency Unit) in Armenia in 1997 to that in 2002?
Ensure brevity in your answer.  0.41. What is the ratio of the Exports (in Local Currency Unit) in France in 1997 to that in 2002?
Ensure brevity in your answer.  0.76. What is the ratio of the Exports (in Local Currency Unit) of Panama in 1997 to that in 2002?
Your answer should be compact. 1.1. What is the ratio of the Exports (in Local Currency Unit) in Singapore in 1997 to that in 2002?
Offer a very short reply. 0.83. What is the ratio of the Exports (in Local Currency Unit) of Armenia in 1998 to that in 1999?
Keep it short and to the point. 0.89. What is the ratio of the Exports (in Local Currency Unit) in France in 1998 to that in 1999?
Your answer should be compact. 0.97. What is the ratio of the Exports (in Local Currency Unit) of Panama in 1998 to that in 1999?
Your answer should be compact. 1.14. What is the ratio of the Exports (in Local Currency Unit) of Singapore in 1998 to that in 1999?
Your response must be concise. 0.93. What is the ratio of the Exports (in Local Currency Unit) of Armenia in 1998 to that in 2000?
Ensure brevity in your answer.  0.75. What is the ratio of the Exports (in Local Currency Unit) of France in 1998 to that in 2000?
Ensure brevity in your answer.  0.84. What is the ratio of the Exports (in Local Currency Unit) in Panama in 1998 to that in 2000?
Provide a short and direct response. 1.03. What is the ratio of the Exports (in Local Currency Unit) of Singapore in 1998 to that in 2000?
Keep it short and to the point. 0.77. What is the ratio of the Exports (in Local Currency Unit) in Armenia in 1998 to that in 2001?
Offer a very short reply. 0.61. What is the ratio of the Exports (in Local Currency Unit) of France in 1998 to that in 2001?
Provide a short and direct response. 0.82. What is the ratio of the Exports (in Local Currency Unit) in Singapore in 1998 to that in 2001?
Offer a terse response. 0.81. What is the ratio of the Exports (in Local Currency Unit) in Armenia in 1998 to that in 2002?
Offer a very short reply. 0.45. What is the ratio of the Exports (in Local Currency Unit) in France in 1998 to that in 2002?
Your response must be concise. 0.81. What is the ratio of the Exports (in Local Currency Unit) of Panama in 1998 to that in 2002?
Your answer should be very brief. 1.05. What is the ratio of the Exports (in Local Currency Unit) in Singapore in 1998 to that in 2002?
Your answer should be very brief. 0.79. What is the ratio of the Exports (in Local Currency Unit) of Armenia in 1999 to that in 2000?
Your answer should be compact. 0.85. What is the ratio of the Exports (in Local Currency Unit) in France in 1999 to that in 2000?
Offer a very short reply. 0.87. What is the ratio of the Exports (in Local Currency Unit) of Panama in 1999 to that in 2000?
Keep it short and to the point. 0.9. What is the ratio of the Exports (in Local Currency Unit) in Singapore in 1999 to that in 2000?
Give a very brief answer. 0.83. What is the ratio of the Exports (in Local Currency Unit) of Armenia in 1999 to that in 2001?
Your answer should be compact. 0.68. What is the ratio of the Exports (in Local Currency Unit) in France in 1999 to that in 2001?
Your response must be concise. 0.84. What is the ratio of the Exports (in Local Currency Unit) in Panama in 1999 to that in 2001?
Offer a terse response. 0.89. What is the ratio of the Exports (in Local Currency Unit) of Singapore in 1999 to that in 2001?
Give a very brief answer. 0.88. What is the ratio of the Exports (in Local Currency Unit) of Armenia in 1999 to that in 2002?
Provide a short and direct response. 0.51. What is the ratio of the Exports (in Local Currency Unit) in France in 1999 to that in 2002?
Offer a very short reply. 0.84. What is the ratio of the Exports (in Local Currency Unit) in Panama in 1999 to that in 2002?
Offer a terse response. 0.92. What is the ratio of the Exports (in Local Currency Unit) of Singapore in 1999 to that in 2002?
Your response must be concise. 0.85. What is the ratio of the Exports (in Local Currency Unit) in Armenia in 2000 to that in 2001?
Ensure brevity in your answer.  0.81. What is the ratio of the Exports (in Local Currency Unit) of France in 2000 to that in 2001?
Your answer should be compact. 0.97. What is the ratio of the Exports (in Local Currency Unit) of Panama in 2000 to that in 2001?
Offer a terse response. 0.98. What is the ratio of the Exports (in Local Currency Unit) of Singapore in 2000 to that in 2001?
Ensure brevity in your answer.  1.06. What is the ratio of the Exports (in Local Currency Unit) of Armenia in 2000 to that in 2002?
Offer a very short reply. 0.6. What is the ratio of the Exports (in Local Currency Unit) of France in 2000 to that in 2002?
Make the answer very short. 0.97. What is the ratio of the Exports (in Local Currency Unit) in Panama in 2000 to that in 2002?
Your response must be concise. 1.02. What is the ratio of the Exports (in Local Currency Unit) of Singapore in 2000 to that in 2002?
Ensure brevity in your answer.  1.02. What is the ratio of the Exports (in Local Currency Unit) of Armenia in 2001 to that in 2002?
Provide a succinct answer. 0.75. What is the ratio of the Exports (in Local Currency Unit) of France in 2001 to that in 2002?
Make the answer very short. 1. What is the ratio of the Exports (in Local Currency Unit) of Panama in 2001 to that in 2002?
Provide a short and direct response. 1.04. What is the difference between the highest and the second highest Exports (in Local Currency Unit) of Armenia?
Offer a terse response. 1.00e+11. What is the difference between the highest and the second highest Exports (in Local Currency Unit) in France?
Make the answer very short. 1.77e+09. What is the difference between the highest and the second highest Exports (in Local Currency Unit) of Panama?
Provide a succinct answer. 4.30e+08. What is the difference between the highest and the second highest Exports (in Local Currency Unit) of Singapore?
Offer a terse response. 6.41e+09. What is the difference between the highest and the lowest Exports (in Local Currency Unit) in Armenia?
Offer a terse response. 2.46e+11. What is the difference between the highest and the lowest Exports (in Local Currency Unit) of France?
Your answer should be very brief. 1.44e+11. What is the difference between the highest and the lowest Exports (in Local Currency Unit) of Panama?
Provide a succinct answer. 1.46e+09. What is the difference between the highest and the lowest Exports (in Local Currency Unit) in Singapore?
Ensure brevity in your answer.  7.32e+1. 